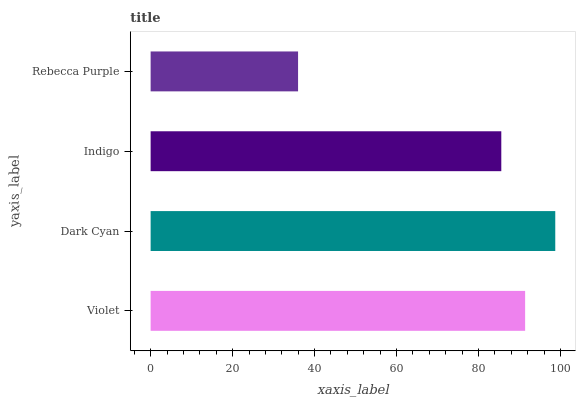Is Rebecca Purple the minimum?
Answer yes or no. Yes. Is Dark Cyan the maximum?
Answer yes or no. Yes. Is Indigo the minimum?
Answer yes or no. No. Is Indigo the maximum?
Answer yes or no. No. Is Dark Cyan greater than Indigo?
Answer yes or no. Yes. Is Indigo less than Dark Cyan?
Answer yes or no. Yes. Is Indigo greater than Dark Cyan?
Answer yes or no. No. Is Dark Cyan less than Indigo?
Answer yes or no. No. Is Violet the high median?
Answer yes or no. Yes. Is Indigo the low median?
Answer yes or no. Yes. Is Indigo the high median?
Answer yes or no. No. Is Dark Cyan the low median?
Answer yes or no. No. 